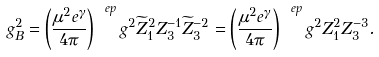<formula> <loc_0><loc_0><loc_500><loc_500>g _ { B } ^ { 2 } = \left ( \frac { \mu ^ { 2 } e ^ { \gamma } } { 4 \pi } \right ) ^ { \ e p } g ^ { 2 } \widetilde { Z } _ { 1 } ^ { 2 } Z _ { 3 } ^ { - 1 } \widetilde { Z } _ { 3 } ^ { - 2 } = \left ( \frac { \mu ^ { 2 } e ^ { \gamma } } { 4 \pi } \right ) ^ { \ e p } g ^ { 2 } Z _ { 1 } ^ { 2 } Z _ { 3 } ^ { - 3 } .</formula> 